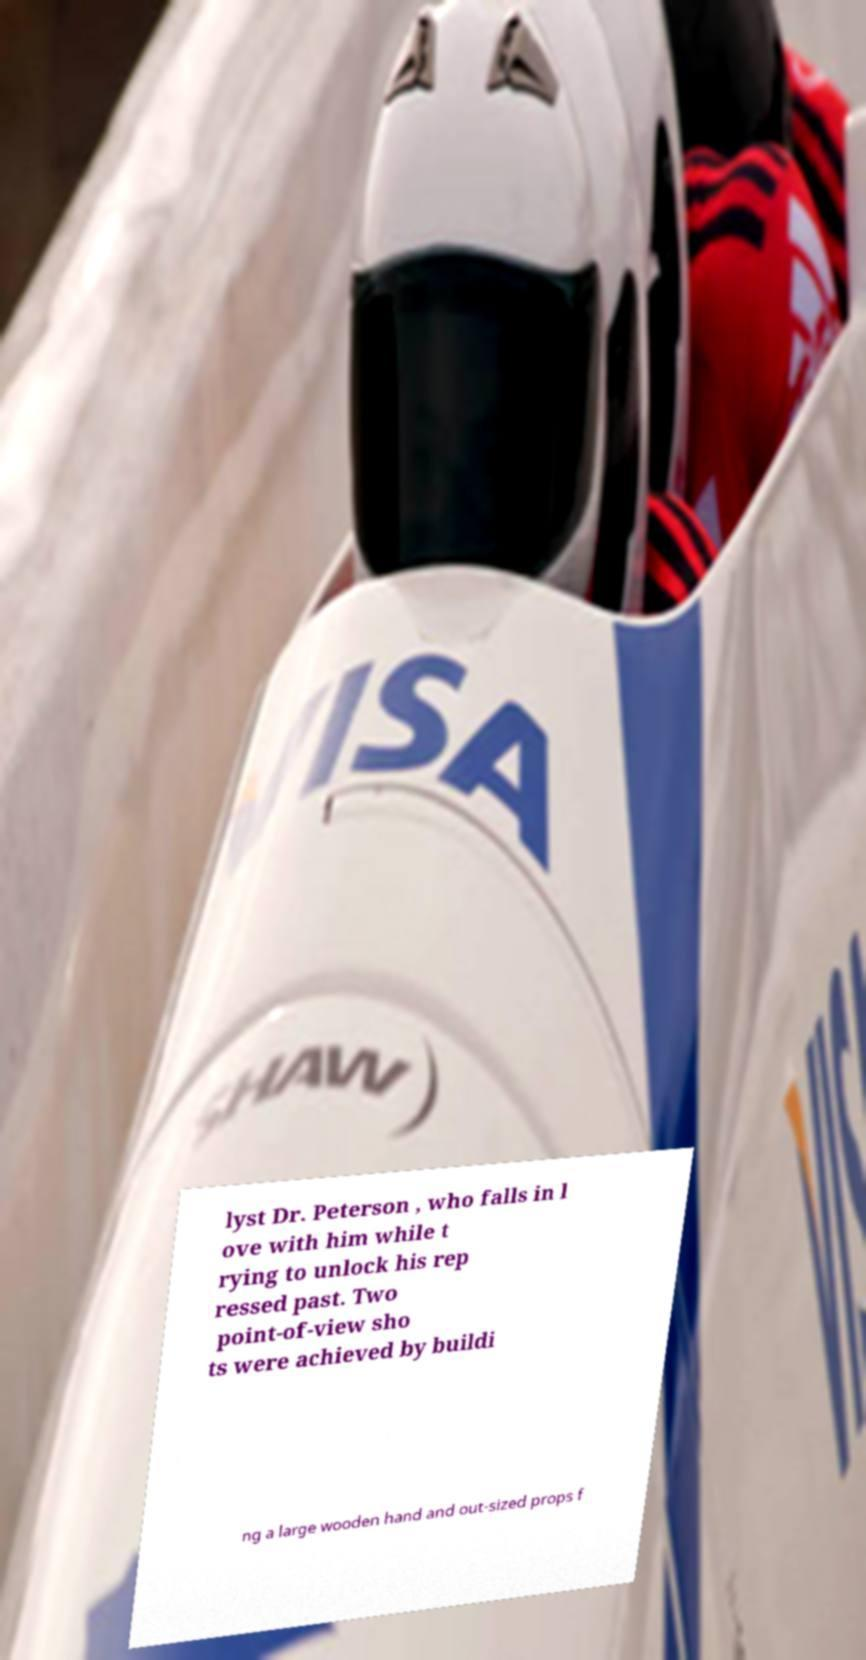What messages or text are displayed in this image? I need them in a readable, typed format. lyst Dr. Peterson , who falls in l ove with him while t rying to unlock his rep ressed past. Two point-of-view sho ts were achieved by buildi ng a large wooden hand and out-sized props f 